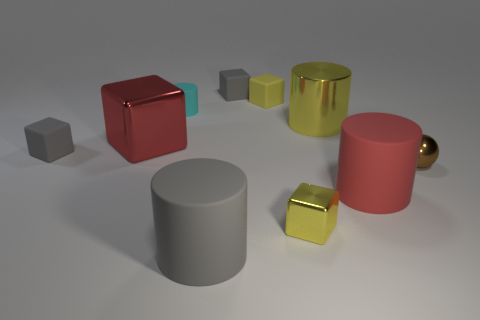Are there an equal number of cylinders behind the big yellow shiny cylinder and gray objects?
Your answer should be compact. No. Is the small metal block the same color as the small cylinder?
Give a very brief answer. No. There is a cube that is both behind the big red rubber cylinder and in front of the big block; how big is it?
Provide a succinct answer. Small. There is another big cylinder that is made of the same material as the red cylinder; what color is it?
Your answer should be compact. Gray. What number of yellow cylinders have the same material as the sphere?
Give a very brief answer. 1. Is the number of big shiny cylinders that are in front of the yellow shiny cylinder the same as the number of big yellow objects that are in front of the tiny metal cube?
Ensure brevity in your answer.  Yes. Do the cyan matte thing and the rubber thing that is to the right of the small shiny block have the same shape?
Make the answer very short. Yes. There is a big thing that is the same color as the large cube; what is its material?
Provide a short and direct response. Rubber. Are there any other things that have the same shape as the yellow rubber object?
Give a very brief answer. Yes. Do the red cube and the small gray block that is behind the small matte cylinder have the same material?
Provide a short and direct response. No. 